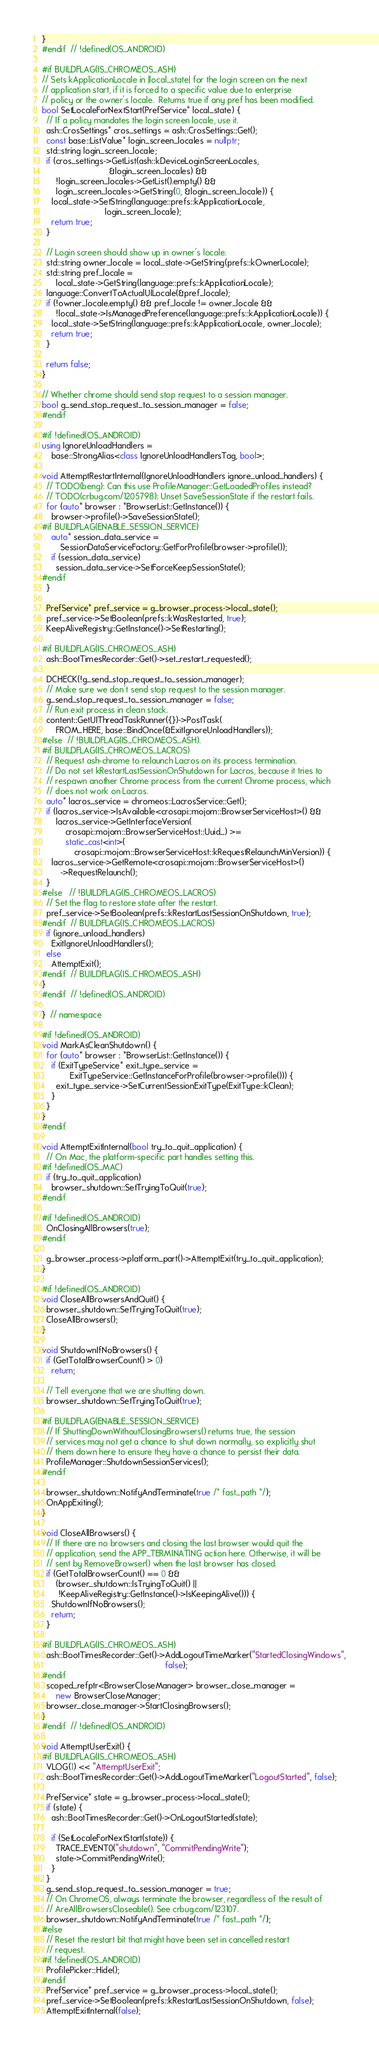<code> <loc_0><loc_0><loc_500><loc_500><_C++_>}
#endif  // !defined(OS_ANDROID)

#if BUILDFLAG(IS_CHROMEOS_ASH)
// Sets kApplicationLocale in |local_state| for the login screen on the next
// application start, if it is forced to a specific value due to enterprise
// policy or the owner's locale.  Returns true if any pref has been modified.
bool SetLocaleForNextStart(PrefService* local_state) {
  // If a policy mandates the login screen locale, use it.
  ash::CrosSettings* cros_settings = ash::CrosSettings::Get();
  const base::ListValue* login_screen_locales = nullptr;
  std::string login_screen_locale;
  if (cros_settings->GetList(ash::kDeviceLoginScreenLocales,
                             &login_screen_locales) &&
      !login_screen_locales->GetList().empty() &&
      login_screen_locales->GetString(0, &login_screen_locale)) {
    local_state->SetString(language::prefs::kApplicationLocale,
                           login_screen_locale);
    return true;
  }

  // Login screen should show up in owner's locale.
  std::string owner_locale = local_state->GetString(prefs::kOwnerLocale);
  std::string pref_locale =
      local_state->GetString(language::prefs::kApplicationLocale);
  language::ConvertToActualUILocale(&pref_locale);
  if (!owner_locale.empty() && pref_locale != owner_locale &&
      !local_state->IsManagedPreference(language::prefs::kApplicationLocale)) {
    local_state->SetString(language::prefs::kApplicationLocale, owner_locale);
    return true;
  }

  return false;
}

// Whether chrome should send stop request to a session manager.
bool g_send_stop_request_to_session_manager = false;
#endif

#if !defined(OS_ANDROID)
using IgnoreUnloadHandlers =
    base::StrongAlias<class IgnoreUnloadHandlersTag, bool>;

void AttemptRestartInternal(IgnoreUnloadHandlers ignore_unload_handlers) {
  // TODO(beng): Can this use ProfileManager::GetLoadedProfiles instead?
  // TODO(crbug.com/1205798): Unset SaveSessionState if the restart fails.
  for (auto* browser : *BrowserList::GetInstance()) {
    browser->profile()->SaveSessionState();
#if BUILDFLAG(ENABLE_SESSION_SERVICE)
    auto* session_data_service =
        SessionDataServiceFactory::GetForProfile(browser->profile());
    if (session_data_service)
      session_data_service->SetForceKeepSessionState();
#endif
  }

  PrefService* pref_service = g_browser_process->local_state();
  pref_service->SetBoolean(prefs::kWasRestarted, true);
  KeepAliveRegistry::GetInstance()->SetRestarting();

#if BUILDFLAG(IS_CHROMEOS_ASH)
  ash::BootTimesRecorder::Get()->set_restart_requested();

  DCHECK(!g_send_stop_request_to_session_manager);
  // Make sure we don't send stop request to the session manager.
  g_send_stop_request_to_session_manager = false;
  // Run exit process in clean stack.
  content::GetUIThreadTaskRunner({})->PostTask(
      FROM_HERE, base::BindOnce(&ExitIgnoreUnloadHandlers));
#else  // !BUILDFLAG(IS_CHROMEOS_ASH).
#if BUILDFLAG(IS_CHROMEOS_LACROS)
  // Request ash-chrome to relaunch Lacros on its process termination.
  // Do not set kRestartLastSessionOnShutdown for Lacros, because it tries to
  // respawn another Chrome process from the current Chrome process, which
  // does not work on Lacros.
  auto* lacros_service = chromeos::LacrosService::Get();
  if (lacros_service->IsAvailable<crosapi::mojom::BrowserServiceHost>() &&
      lacros_service->GetInterfaceVersion(
          crosapi::mojom::BrowserServiceHost::Uuid_) >=
          static_cast<int>(
              crosapi::mojom::BrowserServiceHost::kRequestRelaunchMinVersion)) {
    lacros_service->GetRemote<crosapi::mojom::BrowserServiceHost>()
        ->RequestRelaunch();
  }
#else   // !BUILDFLAG(IS_CHROMEOS_LACROS)
  // Set the flag to restore state after the restart.
  pref_service->SetBoolean(prefs::kRestartLastSessionOnShutdown, true);
#endif  // BUILDFLAG(IS_CHROMEOS_LACROS)
  if (ignore_unload_handlers)
    ExitIgnoreUnloadHandlers();
  else
    AttemptExit();
#endif  // BUILDFLAG(IS_CHROMEOS_ASH)
}
#endif  // !defined(OS_ANDROID)

}  // namespace

#if !defined(OS_ANDROID)
void MarkAsCleanShutdown() {
  for (auto* browser : *BrowserList::GetInstance()) {
    if (ExitTypeService* exit_type_service =
            ExitTypeService::GetInstanceForProfile(browser->profile())) {
      exit_type_service->SetCurrentSessionExitType(ExitType::kClean);
    }
  }
}
#endif

void AttemptExitInternal(bool try_to_quit_application) {
  // On Mac, the platform-specific part handles setting this.
#if !defined(OS_MAC)
  if (try_to_quit_application)
    browser_shutdown::SetTryingToQuit(true);
#endif

#if !defined(OS_ANDROID)
  OnClosingAllBrowsers(true);
#endif

  g_browser_process->platform_part()->AttemptExit(try_to_quit_application);
}

#if !defined(OS_ANDROID)
void CloseAllBrowsersAndQuit() {
  browser_shutdown::SetTryingToQuit(true);
  CloseAllBrowsers();
}

void ShutdownIfNoBrowsers() {
  if (GetTotalBrowserCount() > 0)
    return;

  // Tell everyone that we are shutting down.
  browser_shutdown::SetTryingToQuit(true);

#if BUILDFLAG(ENABLE_SESSION_SERVICE)
  // If ShuttingDownWithoutClosingBrowsers() returns true, the session
  // services may not get a chance to shut down normally, so explicitly shut
  // them down here to ensure they have a chance to persist their data.
  ProfileManager::ShutdownSessionServices();
#endif

  browser_shutdown::NotifyAndTerminate(true /* fast_path */);
  OnAppExiting();
}

void CloseAllBrowsers() {
  // If there are no browsers and closing the last browser would quit the
  // application, send the APP_TERMINATING action here. Otherwise, it will be
  // sent by RemoveBrowser() when the last browser has closed.
  if (GetTotalBrowserCount() == 0 &&
      (browser_shutdown::IsTryingToQuit() ||
       !KeepAliveRegistry::GetInstance()->IsKeepingAlive())) {
    ShutdownIfNoBrowsers();
    return;
  }

#if BUILDFLAG(IS_CHROMEOS_ASH)
  ash::BootTimesRecorder::Get()->AddLogoutTimeMarker("StartedClosingWindows",
                                                     false);
#endif
  scoped_refptr<BrowserCloseManager> browser_close_manager =
      new BrowserCloseManager;
  browser_close_manager->StartClosingBrowsers();
}
#endif  // !defined(OS_ANDROID)

void AttemptUserExit() {
#if BUILDFLAG(IS_CHROMEOS_ASH)
  VLOG(1) << "AttemptUserExit";
  ash::BootTimesRecorder::Get()->AddLogoutTimeMarker("LogoutStarted", false);

  PrefService* state = g_browser_process->local_state();
  if (state) {
    ash::BootTimesRecorder::Get()->OnLogoutStarted(state);

    if (SetLocaleForNextStart(state)) {
      TRACE_EVENT0("shutdown", "CommitPendingWrite");
      state->CommitPendingWrite();
    }
  }
  g_send_stop_request_to_session_manager = true;
  // On ChromeOS, always terminate the browser, regardless of the result of
  // AreAllBrowsersCloseable(). See crbug.com/123107.
  browser_shutdown::NotifyAndTerminate(true /* fast_path */);
#else
  // Reset the restart bit that might have been set in cancelled restart
  // request.
#if !defined(OS_ANDROID)
  ProfilePicker::Hide();
#endif
  PrefService* pref_service = g_browser_process->local_state();
  pref_service->SetBoolean(prefs::kRestartLastSessionOnShutdown, false);
  AttemptExitInternal(false);</code> 